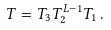Convert formula to latex. <formula><loc_0><loc_0><loc_500><loc_500>T = T _ { 3 } T _ { 2 } ^ { L - 1 } T _ { 1 } \, .</formula> 